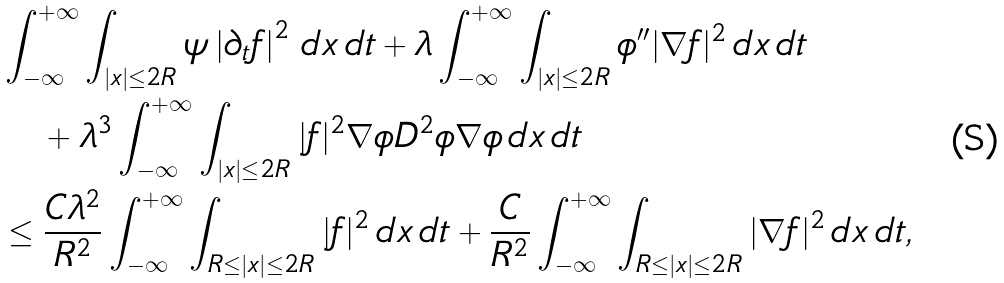<formula> <loc_0><loc_0><loc_500><loc_500>& \int _ { - \infty } ^ { + \infty } \int _ { | x | \leq 2 R } \psi \left | \partial _ { t } f \right | ^ { 2 } \, d x \, d t + \lambda \int _ { - \infty } ^ { + \infty } \int _ { | x | \leq 2 R } \phi ^ { \prime \prime } | \nabla f | ^ { 2 } \, d x \, d t \\ & \quad + \lambda ^ { 3 } \int _ { - \infty } ^ { + \infty } \int _ { | x | \leq 2 R } | f | ^ { 2 } \nabla \phi D ^ { 2 } \phi \nabla \phi \, d x \, d t \\ & \leq \frac { C \lambda ^ { 2 } } { R ^ { 2 } } \int _ { - \infty } ^ { + \infty } \int _ { R \leq | x | \leq 2 R } | f | ^ { 2 } \, d x \, d t + \frac { C } { R ^ { 2 } } \int _ { - \infty } ^ { + \infty } \int _ { R \leq | x | \leq 2 R } | \nabla f | ^ { 2 } \, d x \, d t ,</formula> 